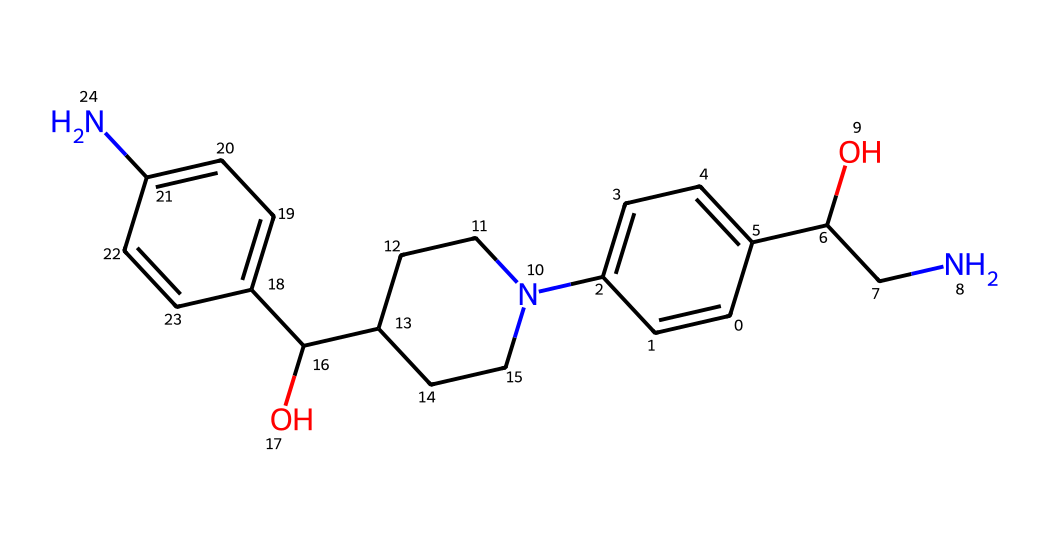What is the overall class of this chemical? The SMILES representation reveals a chemical structure that contains nitrogen atoms and multiple rings, characteristic of antihistamines, which are primarily used to counteract allergic reactions.
Answer: antihistamine How many nitrogen atoms are present? By analyzing the SMILES, we can identify the distinct nitrogen atoms in the structure. There are two nitrogen atoms located within the rings and side chains.
Answer: 2 What functional group is present at the end of the main chain? The hydroxyl group (-OH) can be identified at the end of the main carbon chain in the structure, which is indicative of alcohols and contributes to the solubility of the drug.
Answer: hydroxyl Which part of the chemical is most likely responsible for the antihistaminic activity? The presence of the amine and aromatic ring structures suggest these features are important for binding to histamine receptors, thus playing a crucial role in antihistaminic activity.
Answer: amine How does this antihistamine counteract allergic reactions? This chemical's structure allows it to block histamine receptors, preventing histamine from exerting its effects, therefore alleviating symptoms of allergies.
Answer: block histamine receptors What is the molecular formula corresponding to this SMILES? By interpreting the SMILES representation accurately, we can derive the number of each type of atom: carbons, hydrogens, nitrogens, and oxygens, which leads to a particular molecular formula.
Answer: C18H25N2O3 